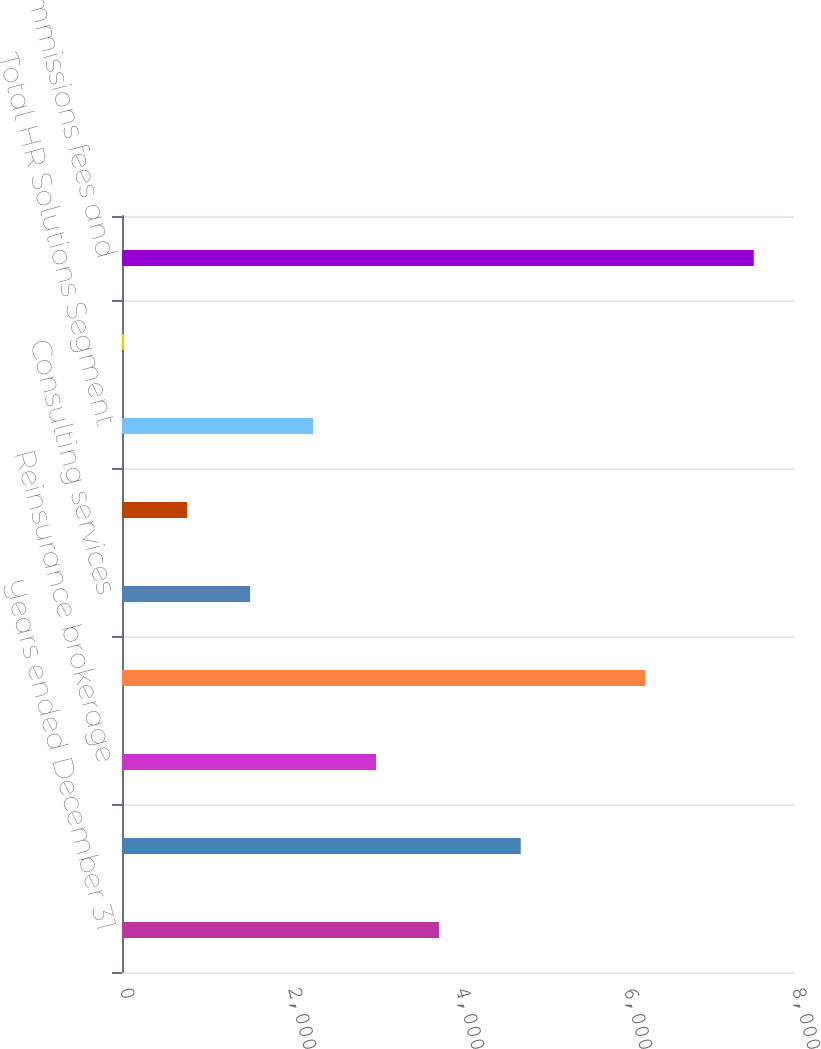<chart> <loc_0><loc_0><loc_500><loc_500><bar_chart><fcel>Years ended December 31<fcel>Retail brokerage<fcel>Reinsurance brokerage<fcel>Total Risk Solutions Segment<fcel>Consulting services<fcel>Outsourcing<fcel>Total HR Solutions Segment<fcel>Intersegment<fcel>Total commissions fees and<nl><fcel>3773.5<fcel>4747<fcel>3024<fcel>6232<fcel>1525<fcel>775.5<fcel>2274.5<fcel>26<fcel>7521<nl></chart> 